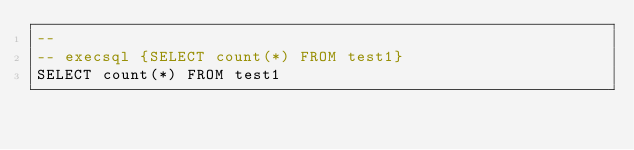Convert code to text. <code><loc_0><loc_0><loc_500><loc_500><_SQL_>-- 
-- execsql {SELECT count(*) FROM test1}
SELECT count(*) FROM test1</code> 